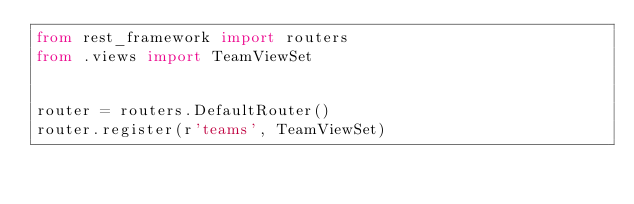Convert code to text. <code><loc_0><loc_0><loc_500><loc_500><_Python_>from rest_framework import routers
from .views import TeamViewSet


router = routers.DefaultRouter()
router.register(r'teams', TeamViewSet)</code> 